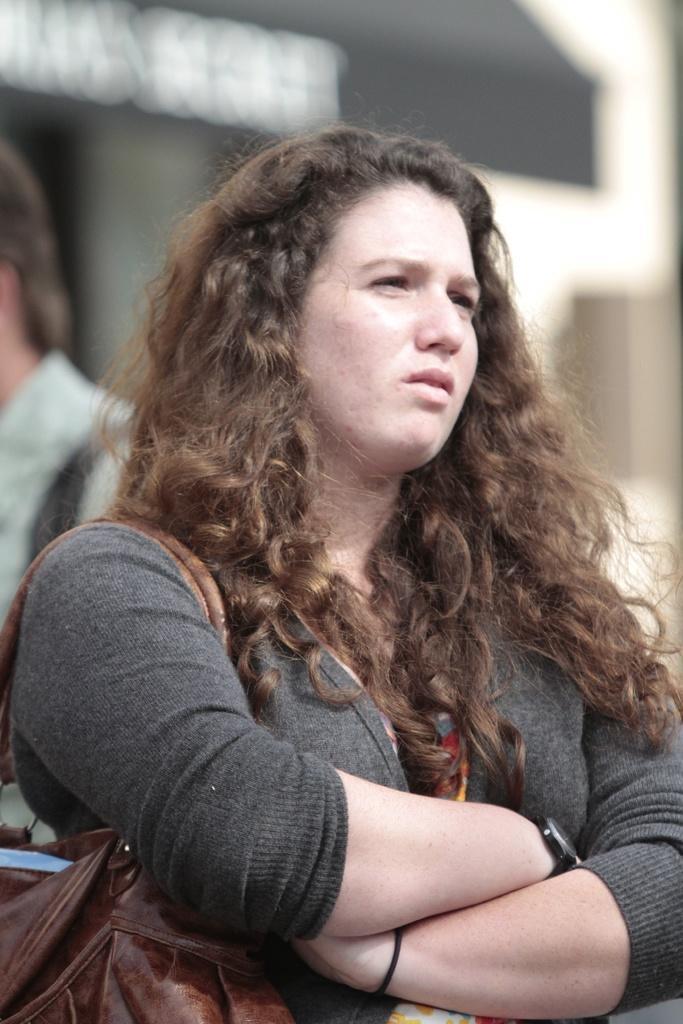Can you describe this image briefly? In this image we can see two persons wearing bags and the background is blurred. 